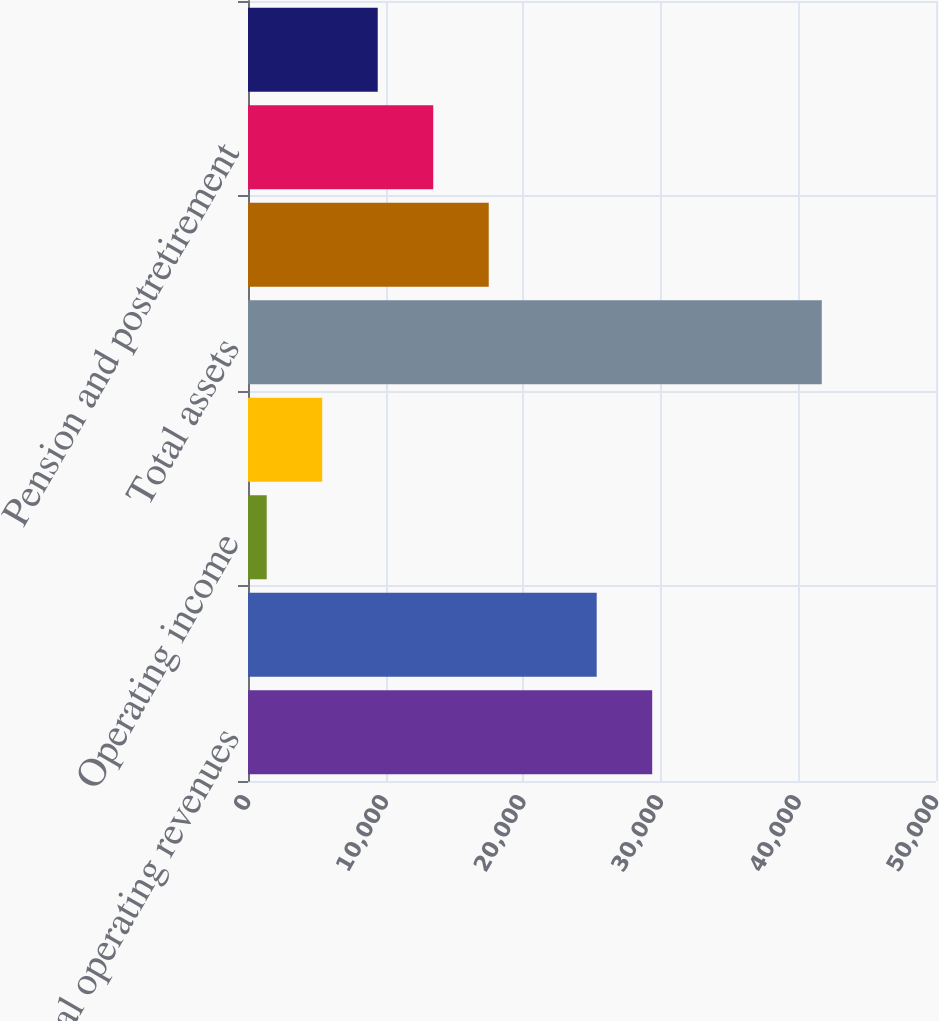<chart> <loc_0><loc_0><loc_500><loc_500><bar_chart><fcel>Total operating revenues<fcel>Total operating expenses<fcel>Operating income<fcel>Net income (loss)<fcel>Total assets<fcel>Long-term debt and capital<fcel>Pension and postretirement<fcel>Stockholder's equity (deficit)<nl><fcel>29374.9<fcel>25341<fcel>1360<fcel>5393.9<fcel>41699<fcel>17495.6<fcel>13461.7<fcel>9427.8<nl></chart> 